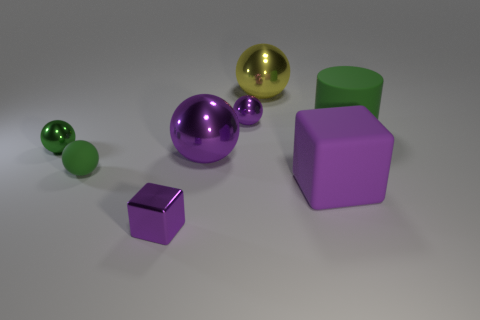Subtract all yellow balls. How many balls are left? 4 Subtract all green shiny balls. How many balls are left? 4 Subtract all red spheres. Subtract all green cubes. How many spheres are left? 5 Add 1 large purple cylinders. How many objects exist? 9 Subtract all cylinders. How many objects are left? 7 Subtract all tiny purple balls. Subtract all tiny green matte spheres. How many objects are left? 6 Add 4 rubber objects. How many rubber objects are left? 7 Add 8 purple cubes. How many purple cubes exist? 10 Subtract 0 red blocks. How many objects are left? 8 